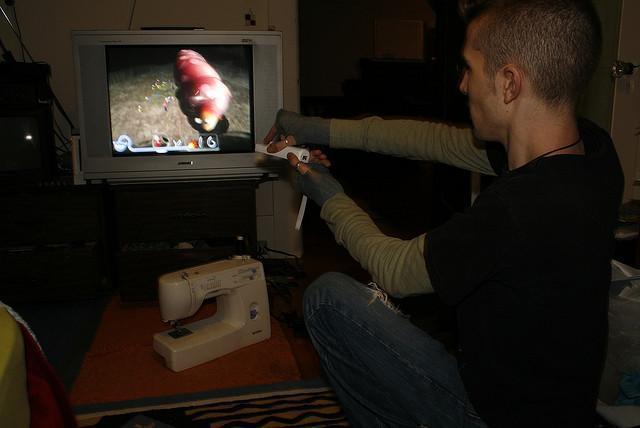The item on the floor looks like what?
Indicate the correct choice and explain in the format: 'Answer: answer
Rationale: rationale.'
Options: Hammer, toad, baby, sewing machine. Answer: sewing machine.
Rationale: It's a portable machine that sews fabrics. 